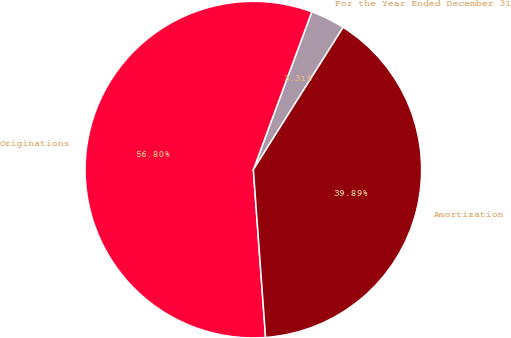Convert chart. <chart><loc_0><loc_0><loc_500><loc_500><pie_chart><fcel>For the Year Ended December 31<fcel>Originations<fcel>Amortization<nl><fcel>3.31%<fcel>56.81%<fcel>39.89%<nl></chart> 